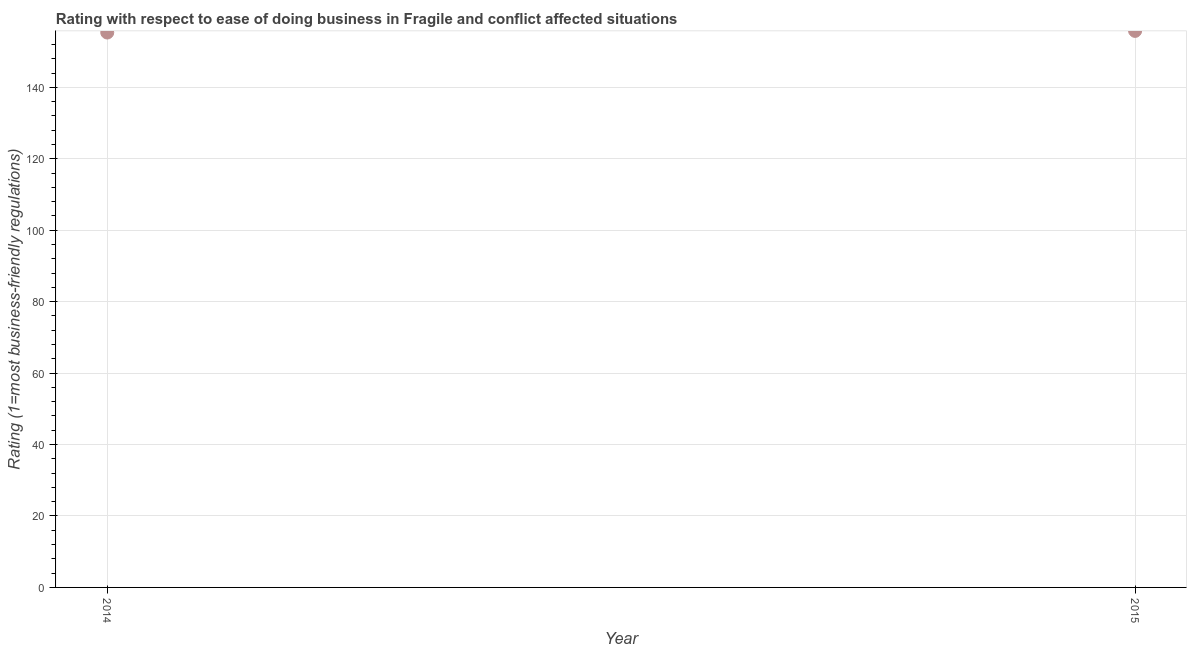What is the ease of doing business index in 2015?
Ensure brevity in your answer.  155.79. Across all years, what is the maximum ease of doing business index?
Give a very brief answer. 155.79. Across all years, what is the minimum ease of doing business index?
Give a very brief answer. 155.33. In which year was the ease of doing business index maximum?
Provide a succinct answer. 2015. What is the sum of the ease of doing business index?
Offer a very short reply. 311.12. What is the difference between the ease of doing business index in 2014 and 2015?
Your response must be concise. -0.45. What is the average ease of doing business index per year?
Your response must be concise. 155.56. What is the median ease of doing business index?
Provide a succinct answer. 155.56. Do a majority of the years between 2015 and 2014 (inclusive) have ease of doing business index greater than 132 ?
Provide a short and direct response. No. What is the ratio of the ease of doing business index in 2014 to that in 2015?
Provide a succinct answer. 1. Is the ease of doing business index in 2014 less than that in 2015?
Make the answer very short. Yes. In how many years, is the ease of doing business index greater than the average ease of doing business index taken over all years?
Provide a succinct answer. 1. Does the ease of doing business index monotonically increase over the years?
Your answer should be compact. Yes. How many dotlines are there?
Offer a terse response. 1. What is the title of the graph?
Offer a terse response. Rating with respect to ease of doing business in Fragile and conflict affected situations. What is the label or title of the X-axis?
Offer a very short reply. Year. What is the label or title of the Y-axis?
Offer a very short reply. Rating (1=most business-friendly regulations). What is the Rating (1=most business-friendly regulations) in 2014?
Your answer should be very brief. 155.33. What is the Rating (1=most business-friendly regulations) in 2015?
Ensure brevity in your answer.  155.79. What is the difference between the Rating (1=most business-friendly regulations) in 2014 and 2015?
Provide a succinct answer. -0.45. 